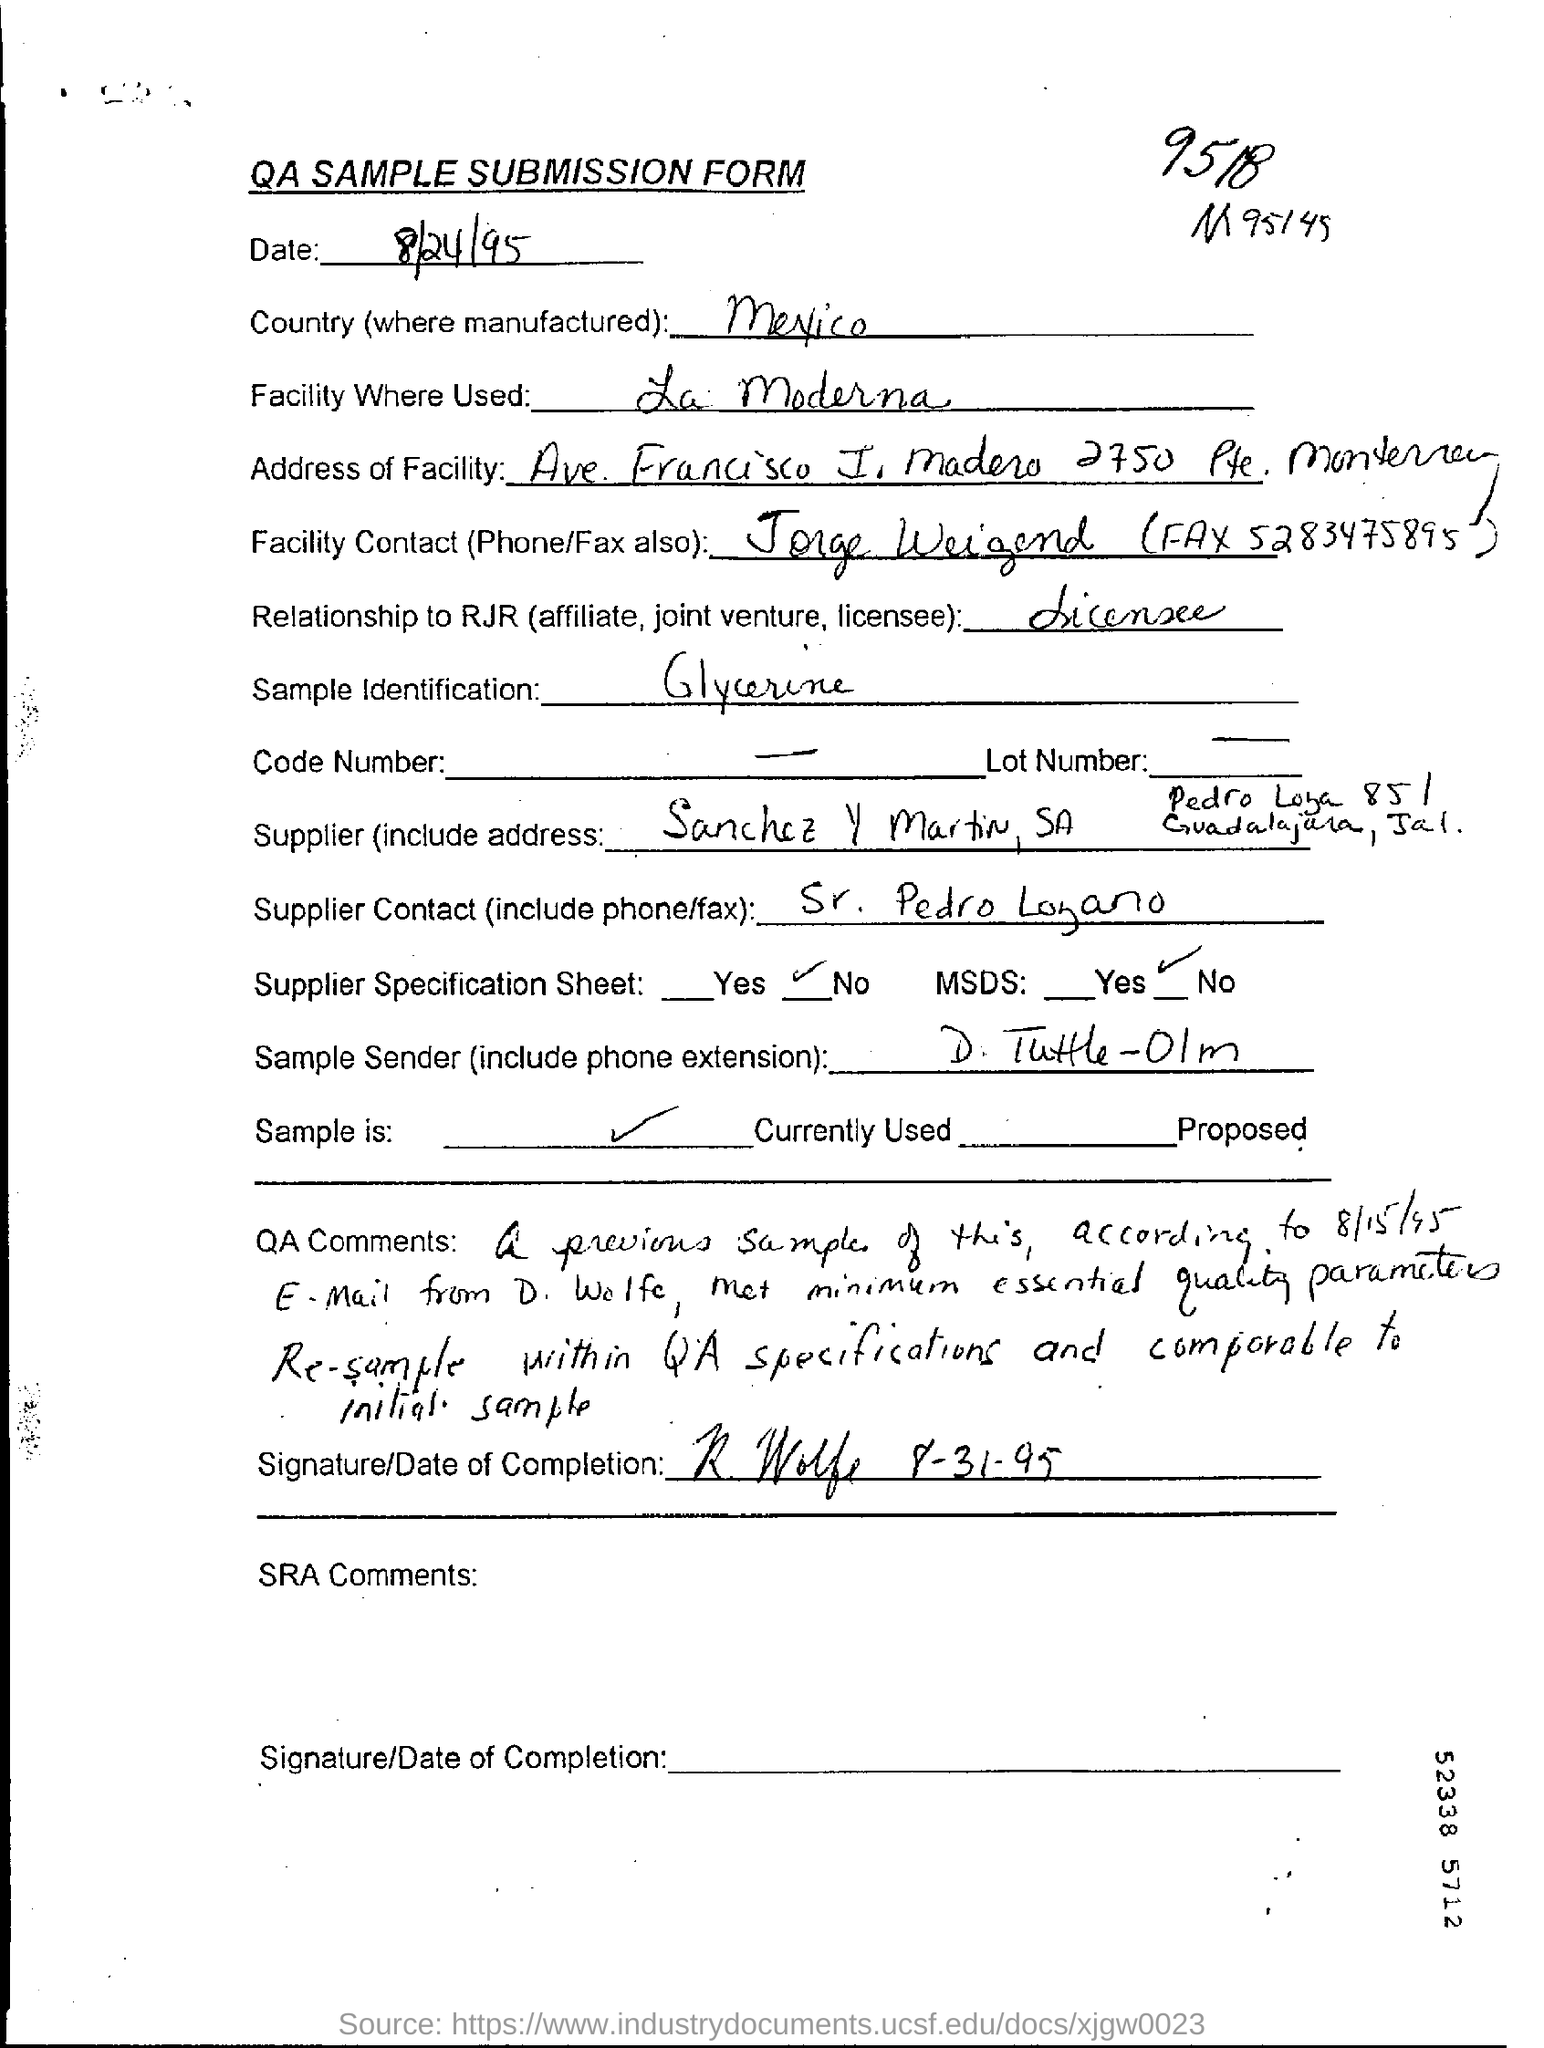Indicate a few pertinent items in this graphic. The country of origin for this product is Mexico. The facility contact is Jorge Weigend, who can be reached via phone at (528) 347-5895 and via fax at (528) 347-5895. The date of submission is August 24, 1995. Simple identification refers to the process of identifying a substance by its physical and chemical properties. In the case of glycerine, it is a clear, odorless liquid that is commonly used in personal care products, cosmetics, and pharmaceuticals, as well as in the production of biofuels and as a humectant. 